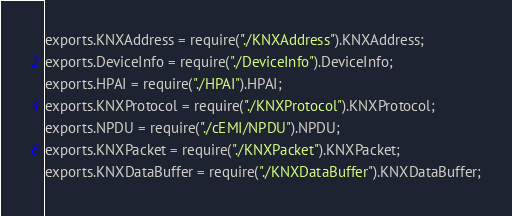Convert code to text. <code><loc_0><loc_0><loc_500><loc_500><_JavaScript_>exports.KNXAddress = require("./KNXAddress").KNXAddress;
exports.DeviceInfo = require("./DeviceInfo").DeviceInfo;
exports.HPAI = require("./HPAI").HPAI;
exports.KNXProtocol = require("./KNXProtocol").KNXProtocol;
exports.NPDU = require("./cEMI/NPDU").NPDU;
exports.KNXPacket = require("./KNXPacket").KNXPacket;
exports.KNXDataBuffer = require("./KNXDataBuffer").KNXDataBuffer;
</code> 